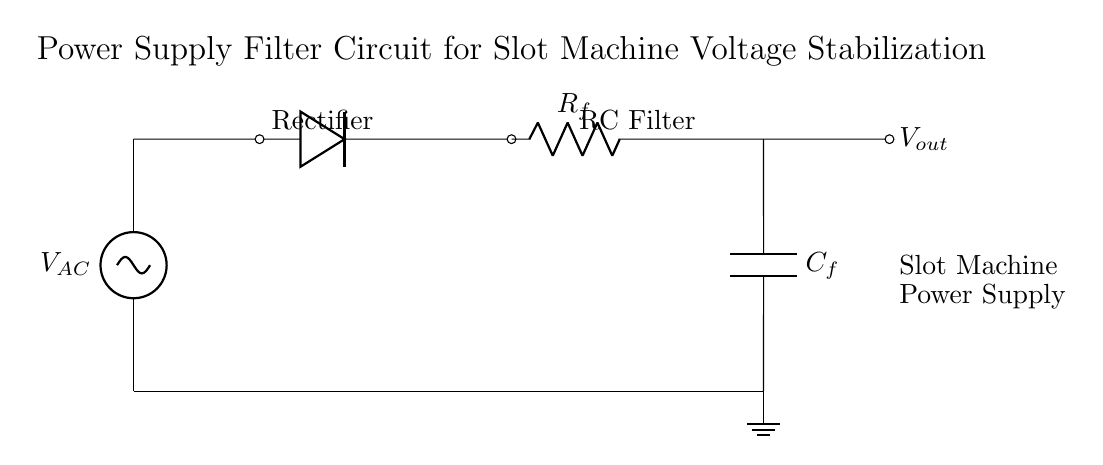What is the type of power source used? The power source is denoted as V_AC, indicating it is an alternating current source. Power sources are labeled in circuits based on their type; here "AC" signifies it is alternating current.
Answer: Alternating current What components make up the rectifier? The rectifier consists of a diode, which allows current to pass in one direction, converting AC to DC. The diagram visually shows the diode positioned in series and connected to the AC source.
Answer: Diode What does the capacitor in this circuit do? The capacitor (C_f) is used for smoothing the output voltage after rectification, reducing ripple and stabilizing the voltage. It stores electrical energy and releases it to maintain a steady output.
Answer: Smoothing What is the function of the resistor in the RC filter? The resistor (R_f) in the RC filter helps control the charge and discharge time of the capacitor, affecting the time constant of the filter, which ultimately influences voltage stability. It works in conjunction with the capacitor to filter the output signal.
Answer: Time constant control What is the output voltage labeled as? The output voltage is labeled as V_out in the diagram, indicating the voltage that is supplied to the next stage, which is the slot machine power supply. This label indicates where the filtered voltage is measured.
Answer: V_out What type of circuit is represented in this diagram? This diagram represents a resistor-capacitor filter circuit, which is a common type used in power supply applications to filter and stabilize voltage. The layout includes a resistor and capacitor in series, characteristic of an RC filter circuit.
Answer: Resistor-capacitor filter 